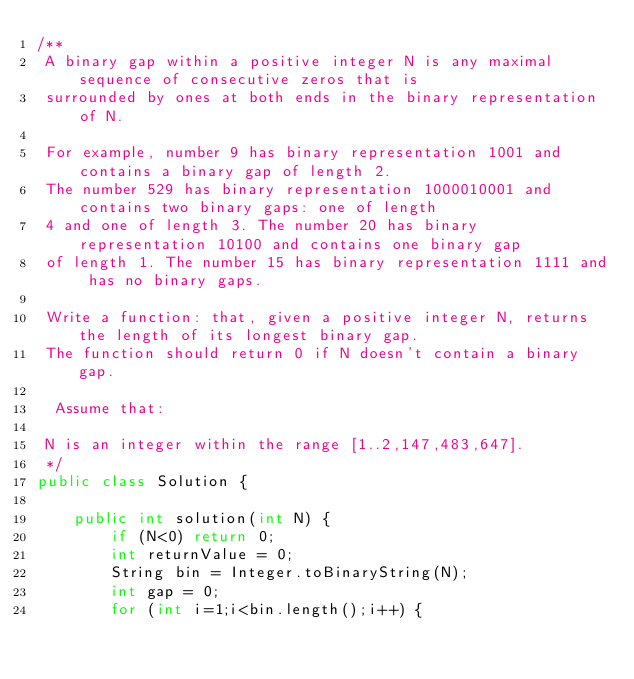Convert code to text. <code><loc_0><loc_0><loc_500><loc_500><_Java_>/**
 A binary gap within a positive integer N is any maximal sequence of consecutive zeros that is
 surrounded by ones at both ends in the binary representation of N.

 For example, number 9 has binary representation 1001 and contains a binary gap of length 2.
 The number 529 has binary representation 1000010001 and contains two binary gaps: one of length
 4 and one of length 3. The number 20 has binary representation 10100 and contains one binary gap
 of length 1. The number 15 has binary representation 1111 and has no binary gaps.

 Write a function: that, given a positive integer N, returns the length of its longest binary gap.
 The function should return 0 if N doesn't contain a binary gap.

  Assume that:

 N is an integer within the range [1..2,147,483,647].
 */
public class Solution {

    public int solution(int N) {
        if (N<0) return 0;
        int returnValue = 0;
        String bin = Integer.toBinaryString(N);
        int gap = 0;
        for (int i=1;i<bin.length();i++) {</code> 